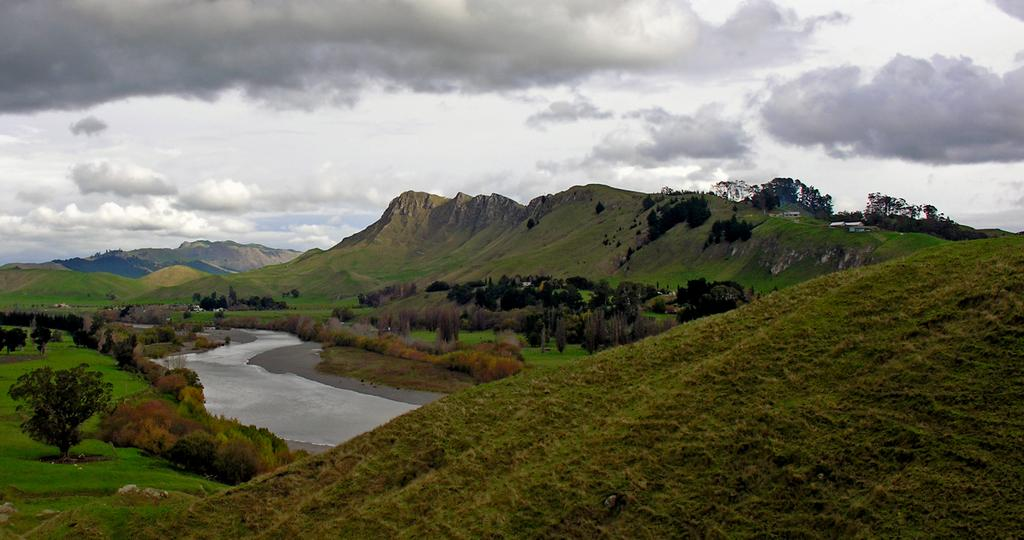Where was the image taken? The image was taken outside. What geographical features can be seen in the image? There are mountains, trees, and a water body in the image. What type of vegetation is present in the image? There is grass in the image. What part of the natural environment is visible in the image? The sky is visible at the top of the image. How many boots are visible in the image? There are no boots present in the image. Are the brothers playing near the water body in the image? There is no mention of brothers or any indication of their presence in the image. 